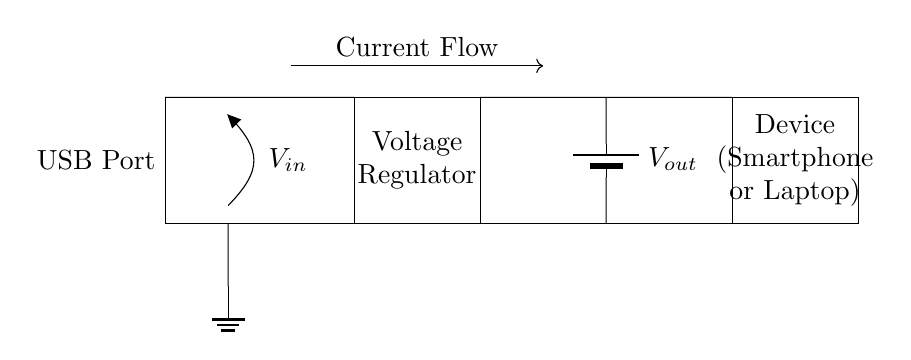What is the input voltage represented in the circuit? The input voltage is labeled as V_in on the left side of the circuit, which shows that this is where the power supply connects to the circuit.
Answer: V_in What is the output of the voltage regulator? The output of the voltage regulator is represented as V_out, which is located on the right side of the circuit and connected to the device.
Answer: V_out How many components are present in this USB charging circuit? The key components in the circuit diagram are: USB port, voltage regulator, output (battery), and device (smartphone/laptop), totaling four components.
Answer: Four What does the arrow in the circuit indicate? The arrow indicates the direction of current flow from the voltage regulator towards the device, highlighting how energy is transmitted through the circuit.
Answer: Current Flow What type of device is connected to the circuit? The device connected to the circuit is labeled as either a smartphone or laptop, indicating the possible users of this charging circuit.
Answer: Smartphone or Laptop What is the main function of the voltage regulator in this circuit? The voltage regulator's main function is to regulate and provide a stable output voltage (V_out) to ensure that the device receives the appropriate voltage level for charging.
Answer: Regulate Voltage Where is the ground connection located in the circuit? The ground connection is indicated at the bottom of the voltage input section, grounding the circuit to complete the current return path.
Answer: Bottom of the circuit 